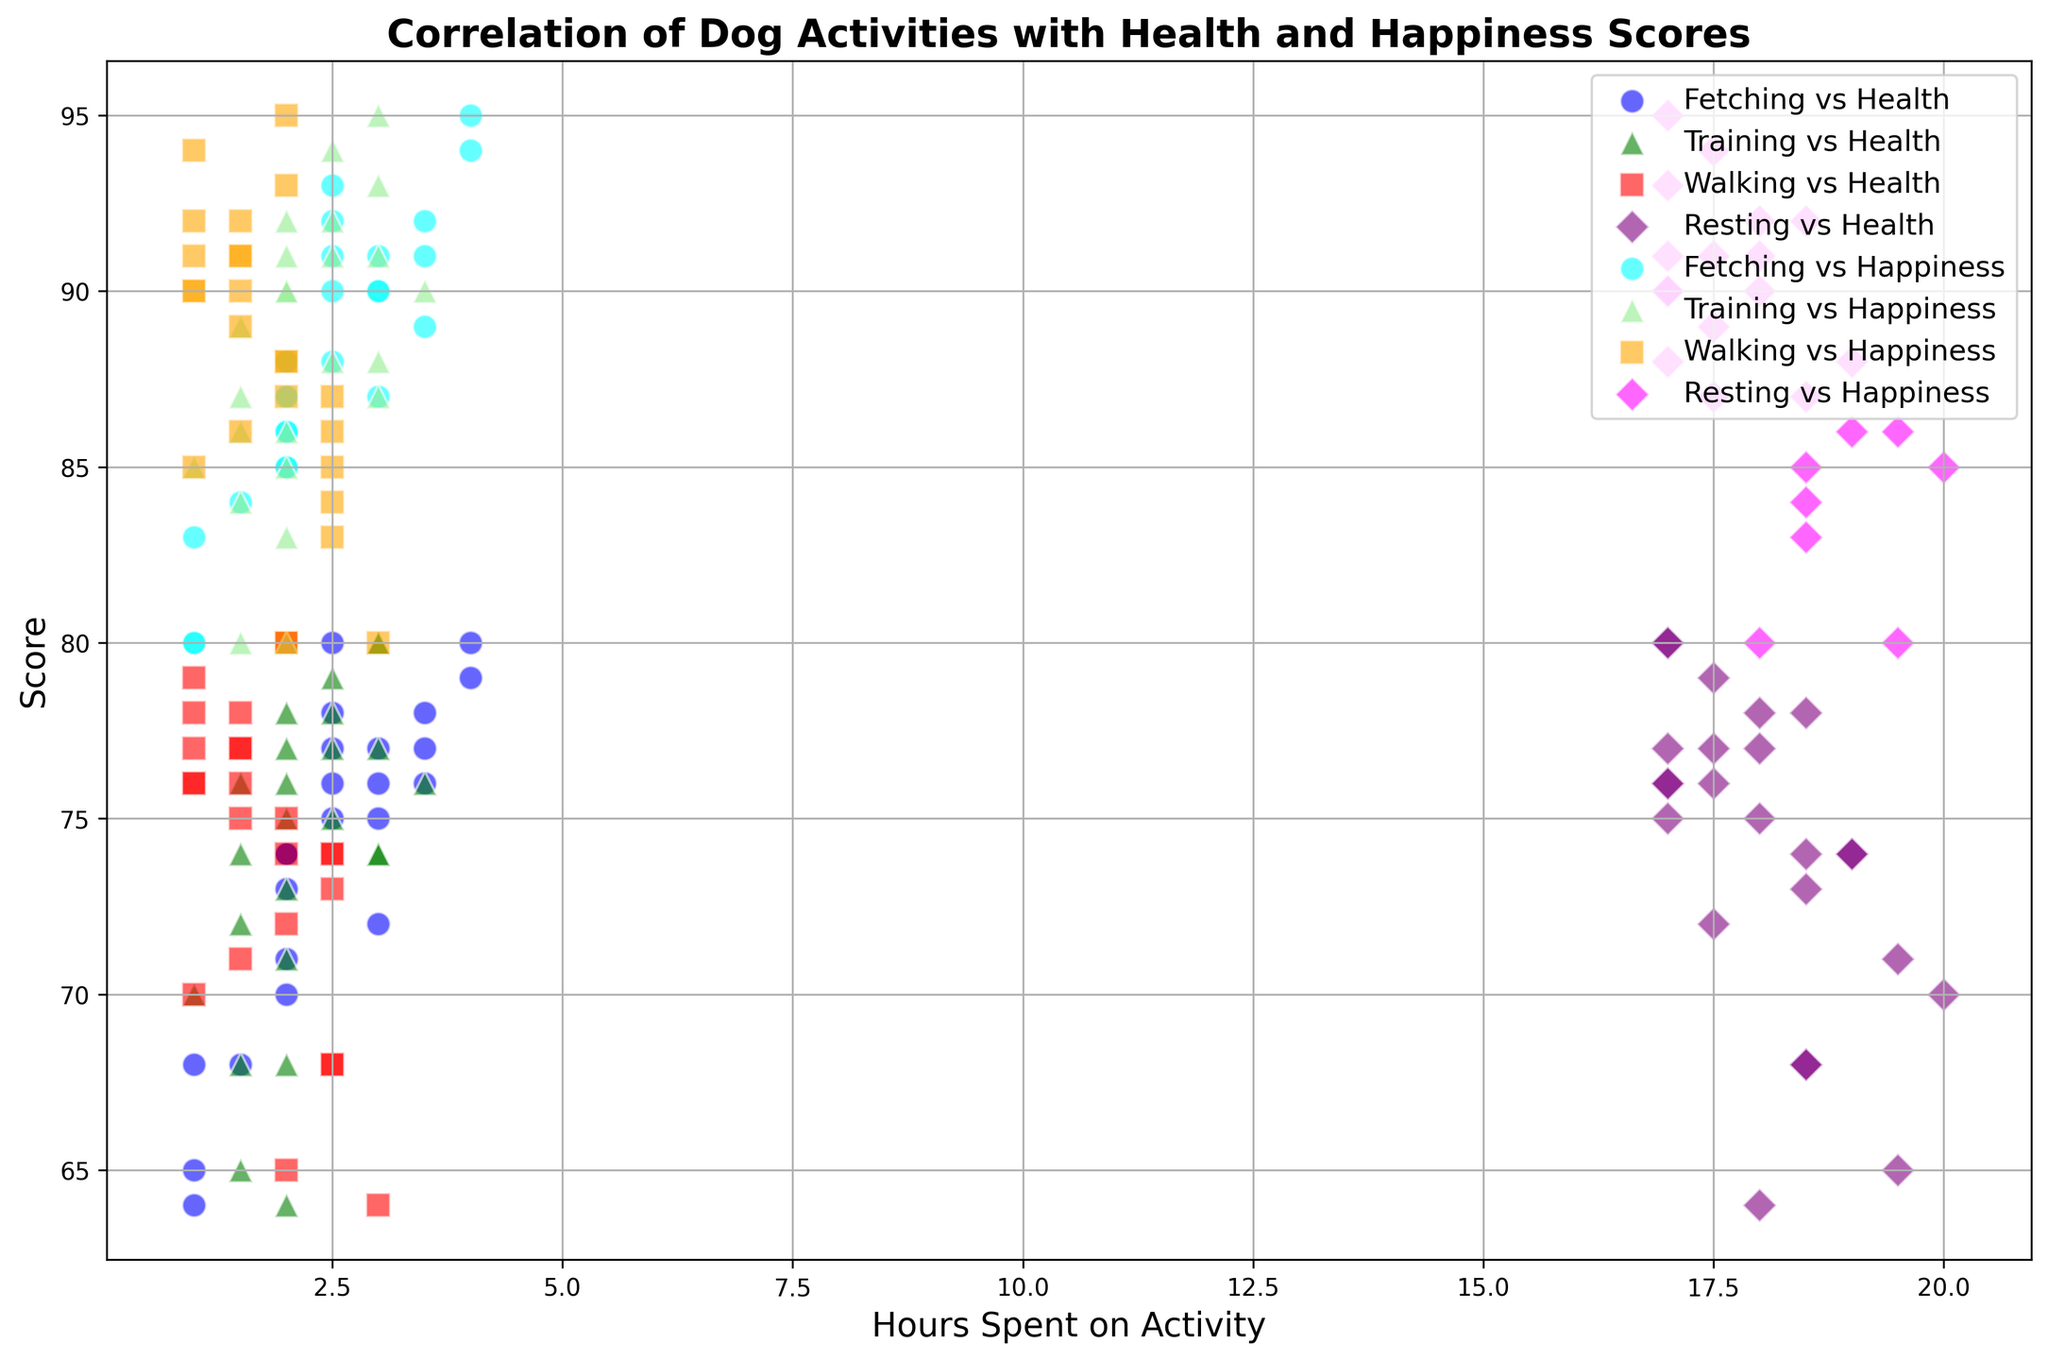What activity correlates most with a higher Health Score? By examining the cluster plot, we see that 'Hours Fetching' (represented by blue dots) is most frequently associated with higher health scores compared to other activities.
Answer: Fetching Which activity shows the least variability in its correlation with Health Score? Looking at the cluster plot, 'Hours Resting' (represented by purple diamonds) shows points that are more consistently grouped together, indicating the least variability in health score correlation.
Answer: Resting Is there any activity correlated with both the highest Health Score and highest Happiness Score? The highest health score (~80) and highest happiness score (95) cluster is associated with 'Hours Fetching' (blue dots) and 'Hours Training' (green triangles).
Answer: Fetching and Training Between 'Hours Walking' and 'Hours Resting', which one has a stronger correlation with higher Happiness Scores? By comparing red squares (walking) and purple diamonds (resting) in the plot, it is evident that 'Hours Walking' (red squares) tends to cluster higher on the happiness score axis.
Answer: Walking Which activity results in the lowest Health Scores? By observing the plot, 'Hours Walking' (red squares) consistently shows lower health scores compared to other activities.
Answer: Walking Which colored markers are used for representing 'Walking' activities in the plot? The plot shows 'Hours Walking' represented by red squares.
Answer: Red squares How does 'Hours Training' correlate with Health and Happiness Scores on average? The green triangles representing 'Hours Training’ generally indicate higher averages for both health and happiness scores. We can estimate this because these points cluster relatively high on both axes.
Answer: Positive correlation Which activity demonstrates the most balance in correlating with both high Health and Happiness Scores? The scatter plot demonstrates that 'Hours Training' (green triangles) has high clusters in both health and happiness scores, signifying a balanced positive correlation with both.
Answer: Training What's the visual difference between the markers used for Fetching and Training activities? 'Hours Fetching' is shown with blue circles, while 'Hours Training' is shown with green triangles, making them easy to distinguish.
Answer: Circles and Triangles 